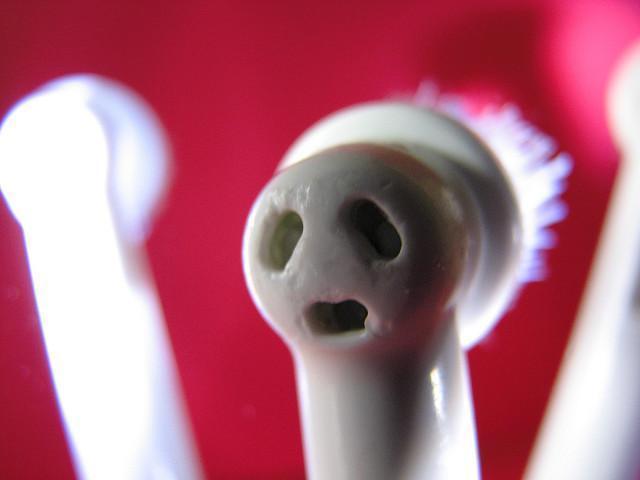How many toothbrushes are in the picture?
Give a very brief answer. 3. How many women in brown hats are there?
Give a very brief answer. 0. 